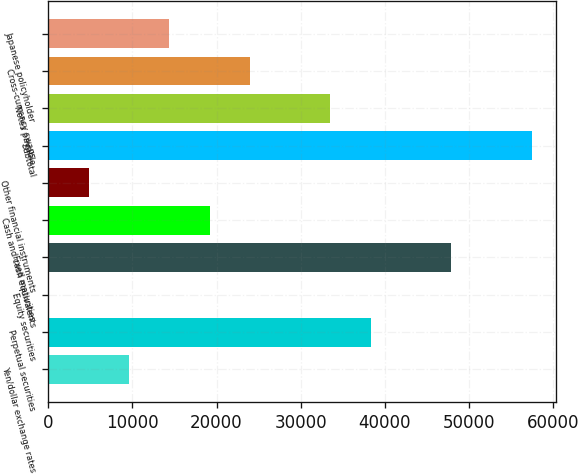<chart> <loc_0><loc_0><loc_500><loc_500><bar_chart><fcel>Yen/dollar exchange rates<fcel>Perpetual securities<fcel>Equity securities<fcel>Fixed maturities<fcel>Cash and cash equivalents<fcel>Other financial instruments<fcel>Subtotal<fcel>Notes payable<fcel>Cross-currency swaps<fcel>Japanese policyholder<nl><fcel>9601.2<fcel>38320.8<fcel>28<fcel>47894<fcel>19174.4<fcel>4814.6<fcel>57467.2<fcel>33534.2<fcel>23961<fcel>14387.8<nl></chart> 